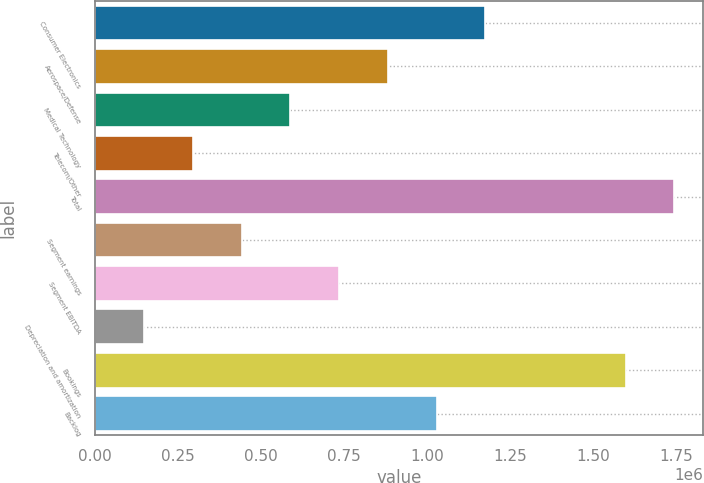Convert chart. <chart><loc_0><loc_0><loc_500><loc_500><bar_chart><fcel>Consumer Electronics<fcel>Aerospace/Defense<fcel>Medical Technology<fcel>Telecom/Other<fcel>Total<fcel>Segment earnings<fcel>Segment EBITDA<fcel>Depreciation and amortization<fcel>Bookings<fcel>Backlog<nl><fcel>1.17593e+06<fcel>882371<fcel>588813<fcel>295254<fcel>1.74476e+06<fcel>442033<fcel>735592<fcel>148475<fcel>1.59798e+06<fcel>1.02915e+06<nl></chart> 